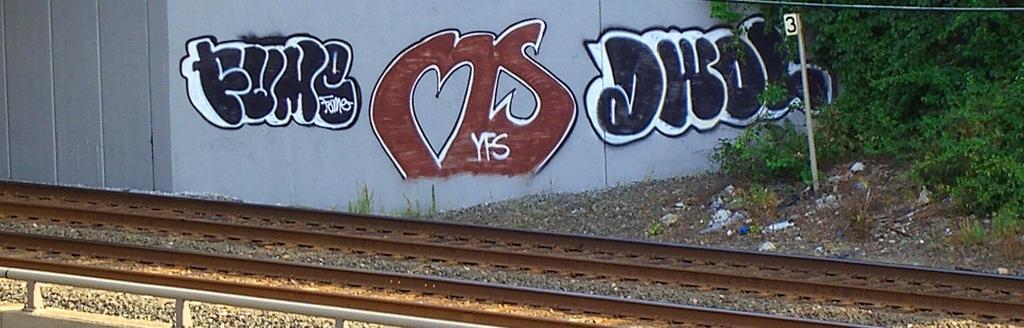What is depicted on the wall in the image? There is graffiti on a wall in the image. What is attached to the pole in the image? There is a number on the pole in the image. What type of vegetation can be seen in the image? There are trees visible in the image. What is the surface of the track in the image made of? The track in the image has stones at the bottom. Can you describe the leg of the person who wrote the graffiti in the image? There is no person depicted in the image, so it is not possible to describe their leg. What type of fruit is hanging from the trees in the image? There are no fruits visible in the image; only trees are present. 